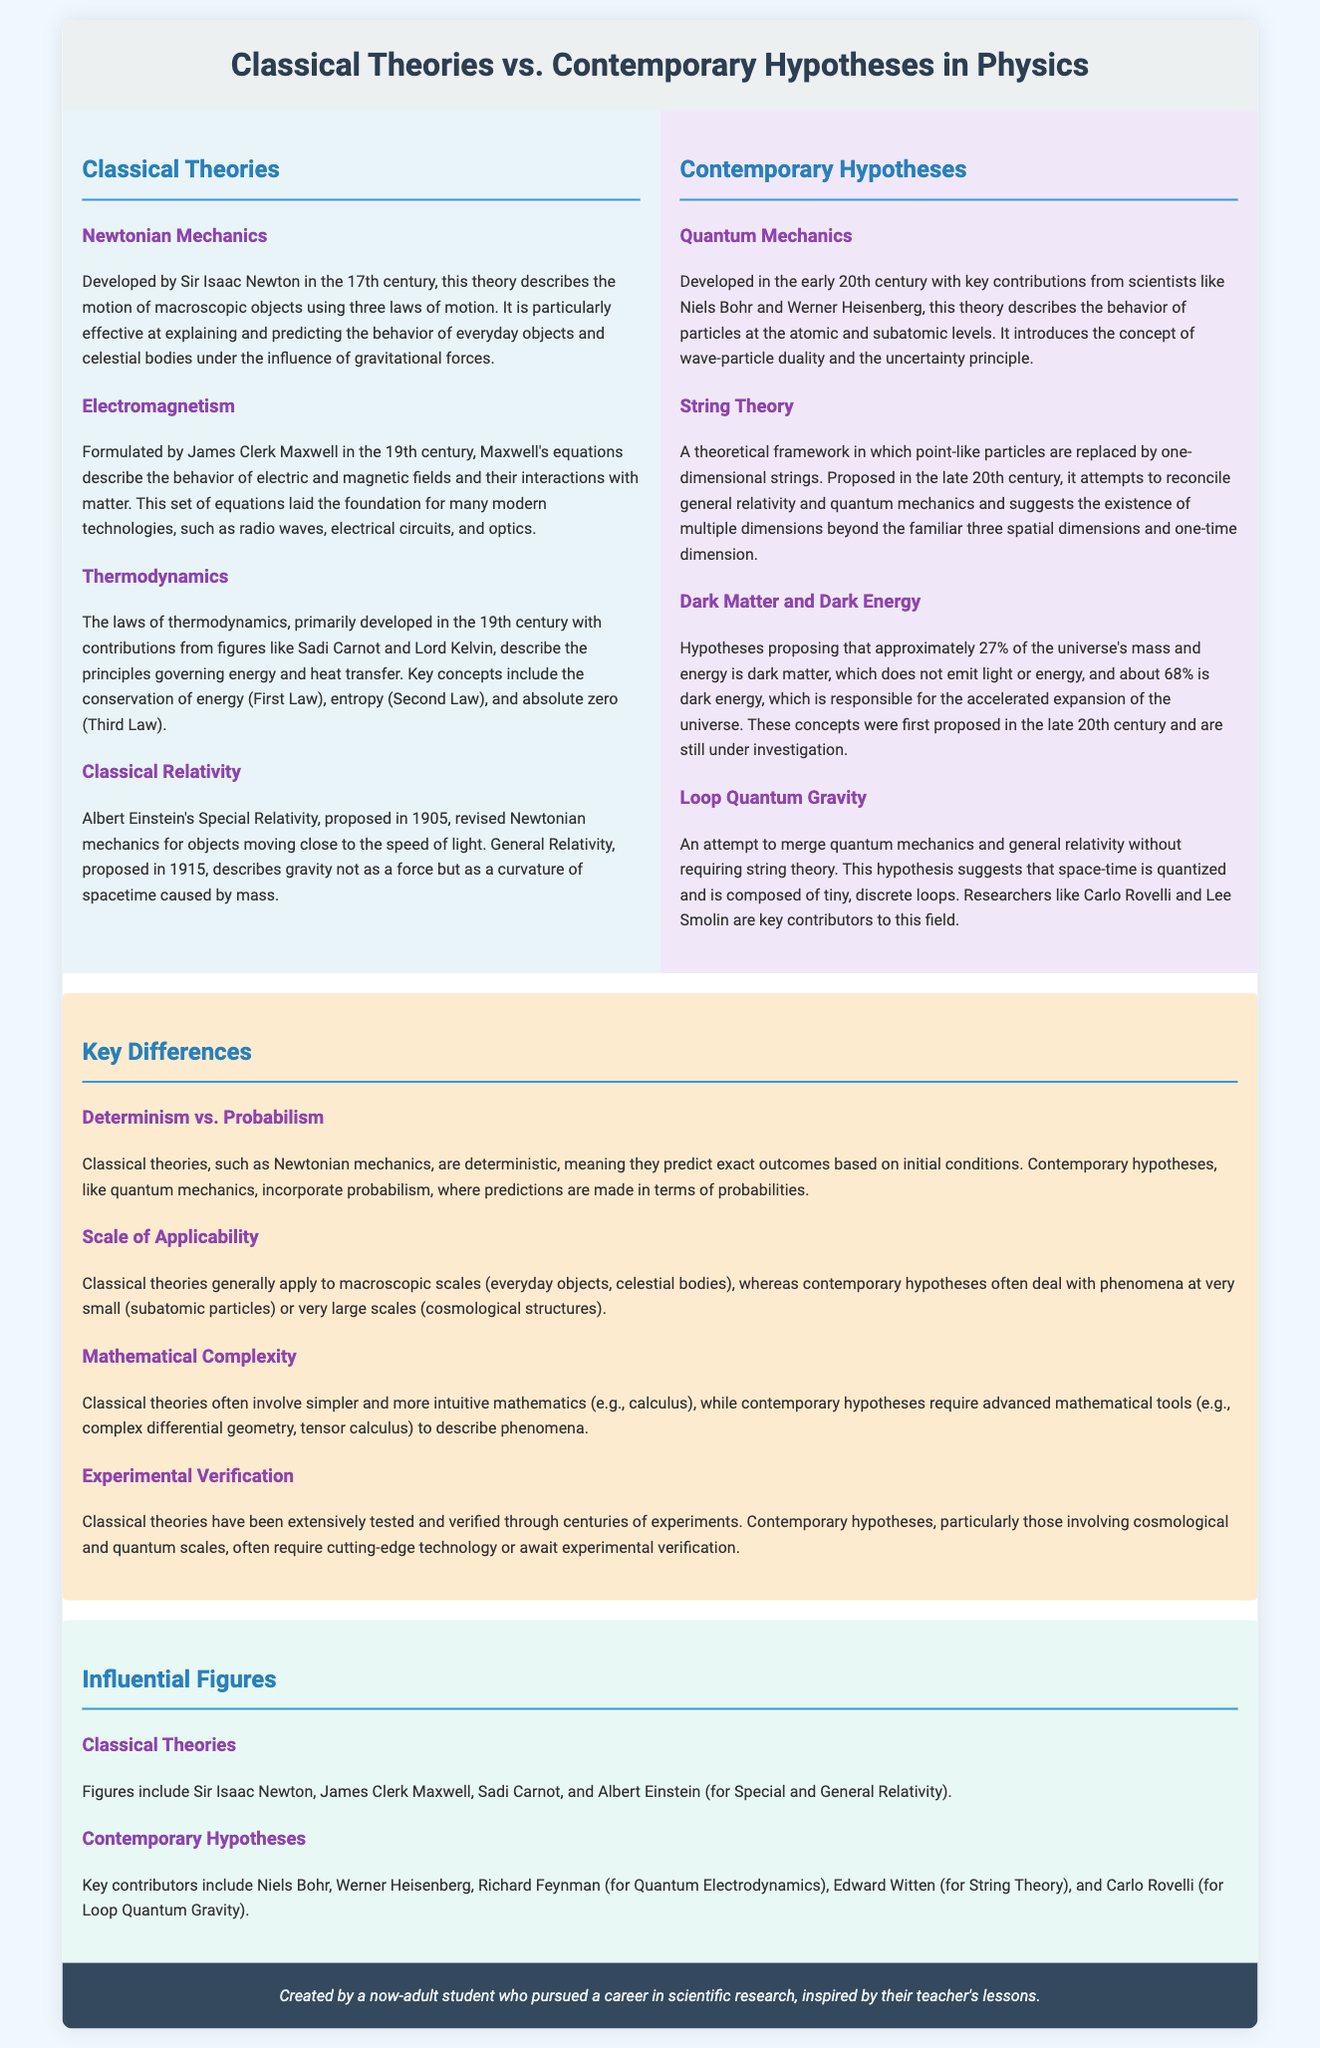What is the main focus of Classical Theories? The main focus of Classical Theories is to describe the motion of macroscopic objects and the principles governing energy and heat transfer.
Answer: Motion of macroscopic objects Who developed the laws of thermodynamics? The laws of thermodynamics were developed with contributions from figures like Sadi Carnot and Lord Kelvin.
Answer: Sadi Carnot and Lord Kelvin What is the foundational equation set for electromagnetism? Maxwell's equations describe the behavior of electric and magnetic fields and their interactions with matter.
Answer: Maxwell's equations Which theory introduces the concept of wave-particle duality? The theory that introduces the concept of wave-particle duality is Quantum Mechanics.
Answer: Quantum Mechanics What is a key feature of String Theory? String Theory suggests the existence of multiple dimensions beyond the familiar three spatial dimensions and one-time dimension.
Answer: Multiple dimensions What do Classical Theories assume about predictability? Classical Theories are deterministic, meaning they predict exact outcomes based on initial conditions.
Answer: Deterministic What mathematical tools are often required for contemporary hypotheses? Contemporary hypotheses require advanced mathematical tools, such as complex differential geometry and tensor calculus.
Answer: Complex differential geometry and tensor calculus What percentage of the universe is hypothesized to be dark energy? Approximately 68% of the universe's mass and energy is hypothesized to be dark energy.
Answer: 68% Who is a key contributor to Loop Quantum Gravity? Carlo Rovelli is a key contributor to Loop Quantum Gravity.
Answer: Carlo Rovelli 